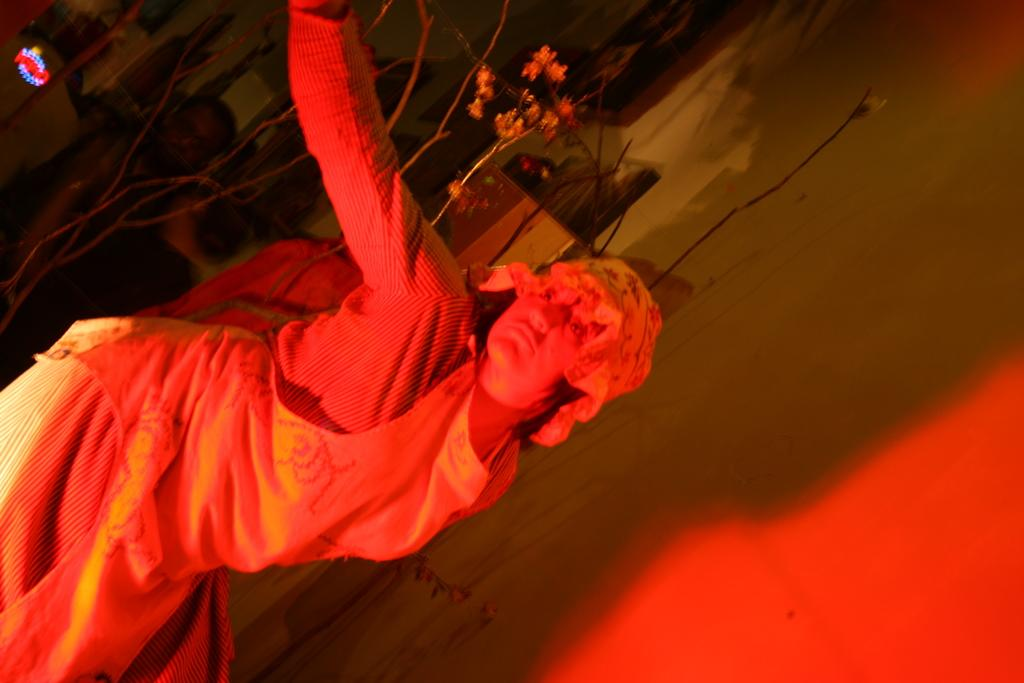Who is the main subject in the image? There is a person in the image. Can you describe the background of the image? There are plants and a wall in the background of the image. Are there any other people visible in the image? Yes, there is another person in the background of the image. What type of religion is being practiced by the person in the image? There is no indication of any religious practice in the image. 